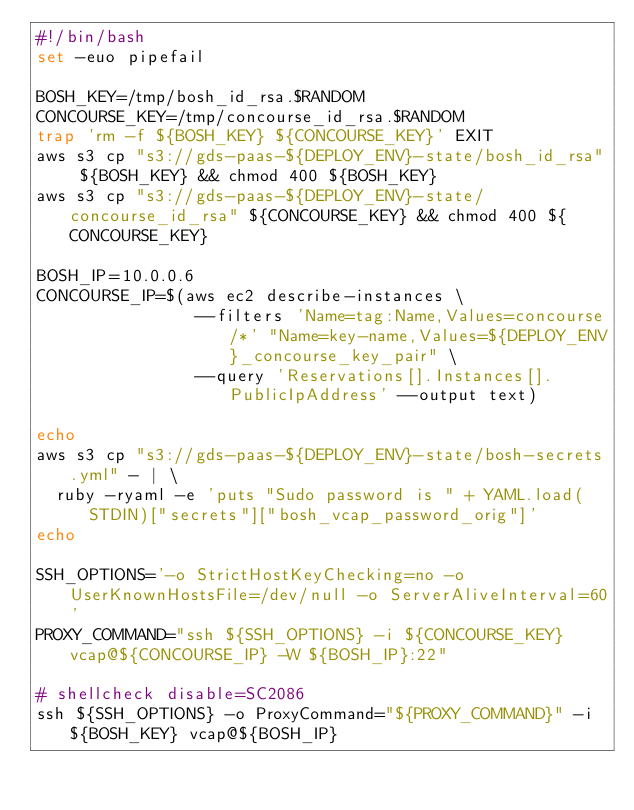Convert code to text. <code><loc_0><loc_0><loc_500><loc_500><_Bash_>#!/bin/bash
set -euo pipefail

BOSH_KEY=/tmp/bosh_id_rsa.$RANDOM
CONCOURSE_KEY=/tmp/concourse_id_rsa.$RANDOM
trap 'rm -f ${BOSH_KEY} ${CONCOURSE_KEY}' EXIT
aws s3 cp "s3://gds-paas-${DEPLOY_ENV}-state/bosh_id_rsa" ${BOSH_KEY} && chmod 400 ${BOSH_KEY}
aws s3 cp "s3://gds-paas-${DEPLOY_ENV}-state/concourse_id_rsa" ${CONCOURSE_KEY} && chmod 400 ${CONCOURSE_KEY}

BOSH_IP=10.0.0.6
CONCOURSE_IP=$(aws ec2 describe-instances \
                --filters 'Name=tag:Name,Values=concourse/*' "Name=key-name,Values=${DEPLOY_ENV}_concourse_key_pair" \
                --query 'Reservations[].Instances[].PublicIpAddress' --output text)

echo
aws s3 cp "s3://gds-paas-${DEPLOY_ENV}-state/bosh-secrets.yml" - | \
  ruby -ryaml -e 'puts "Sudo password is " + YAML.load(STDIN)["secrets"]["bosh_vcap_password_orig"]'
echo

SSH_OPTIONS='-o StrictHostKeyChecking=no -o UserKnownHostsFile=/dev/null -o ServerAliveInterval=60'
PROXY_COMMAND="ssh ${SSH_OPTIONS} -i ${CONCOURSE_KEY} vcap@${CONCOURSE_IP} -W ${BOSH_IP}:22"

# shellcheck disable=SC2086
ssh ${SSH_OPTIONS} -o ProxyCommand="${PROXY_COMMAND}" -i ${BOSH_KEY} vcap@${BOSH_IP}
</code> 